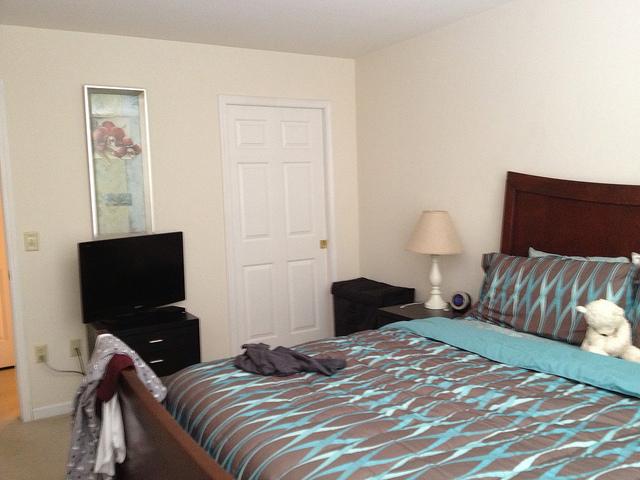What is this room for?
Keep it brief. Sleeping. Is there a stuffed animal on the bed?
Answer briefly. Yes. Is the TV on?
Short answer required. No. 